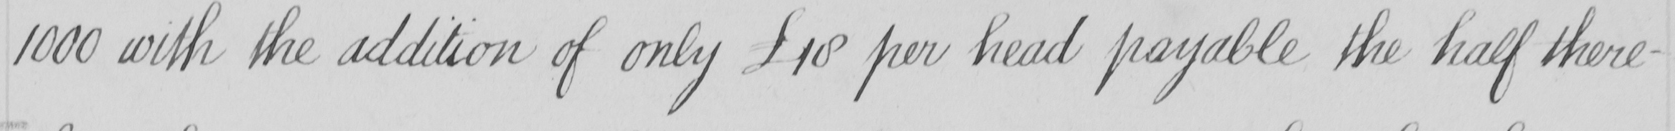Please transcribe the handwritten text in this image. 1000 with the addition of only £10 per head payable the half there- 